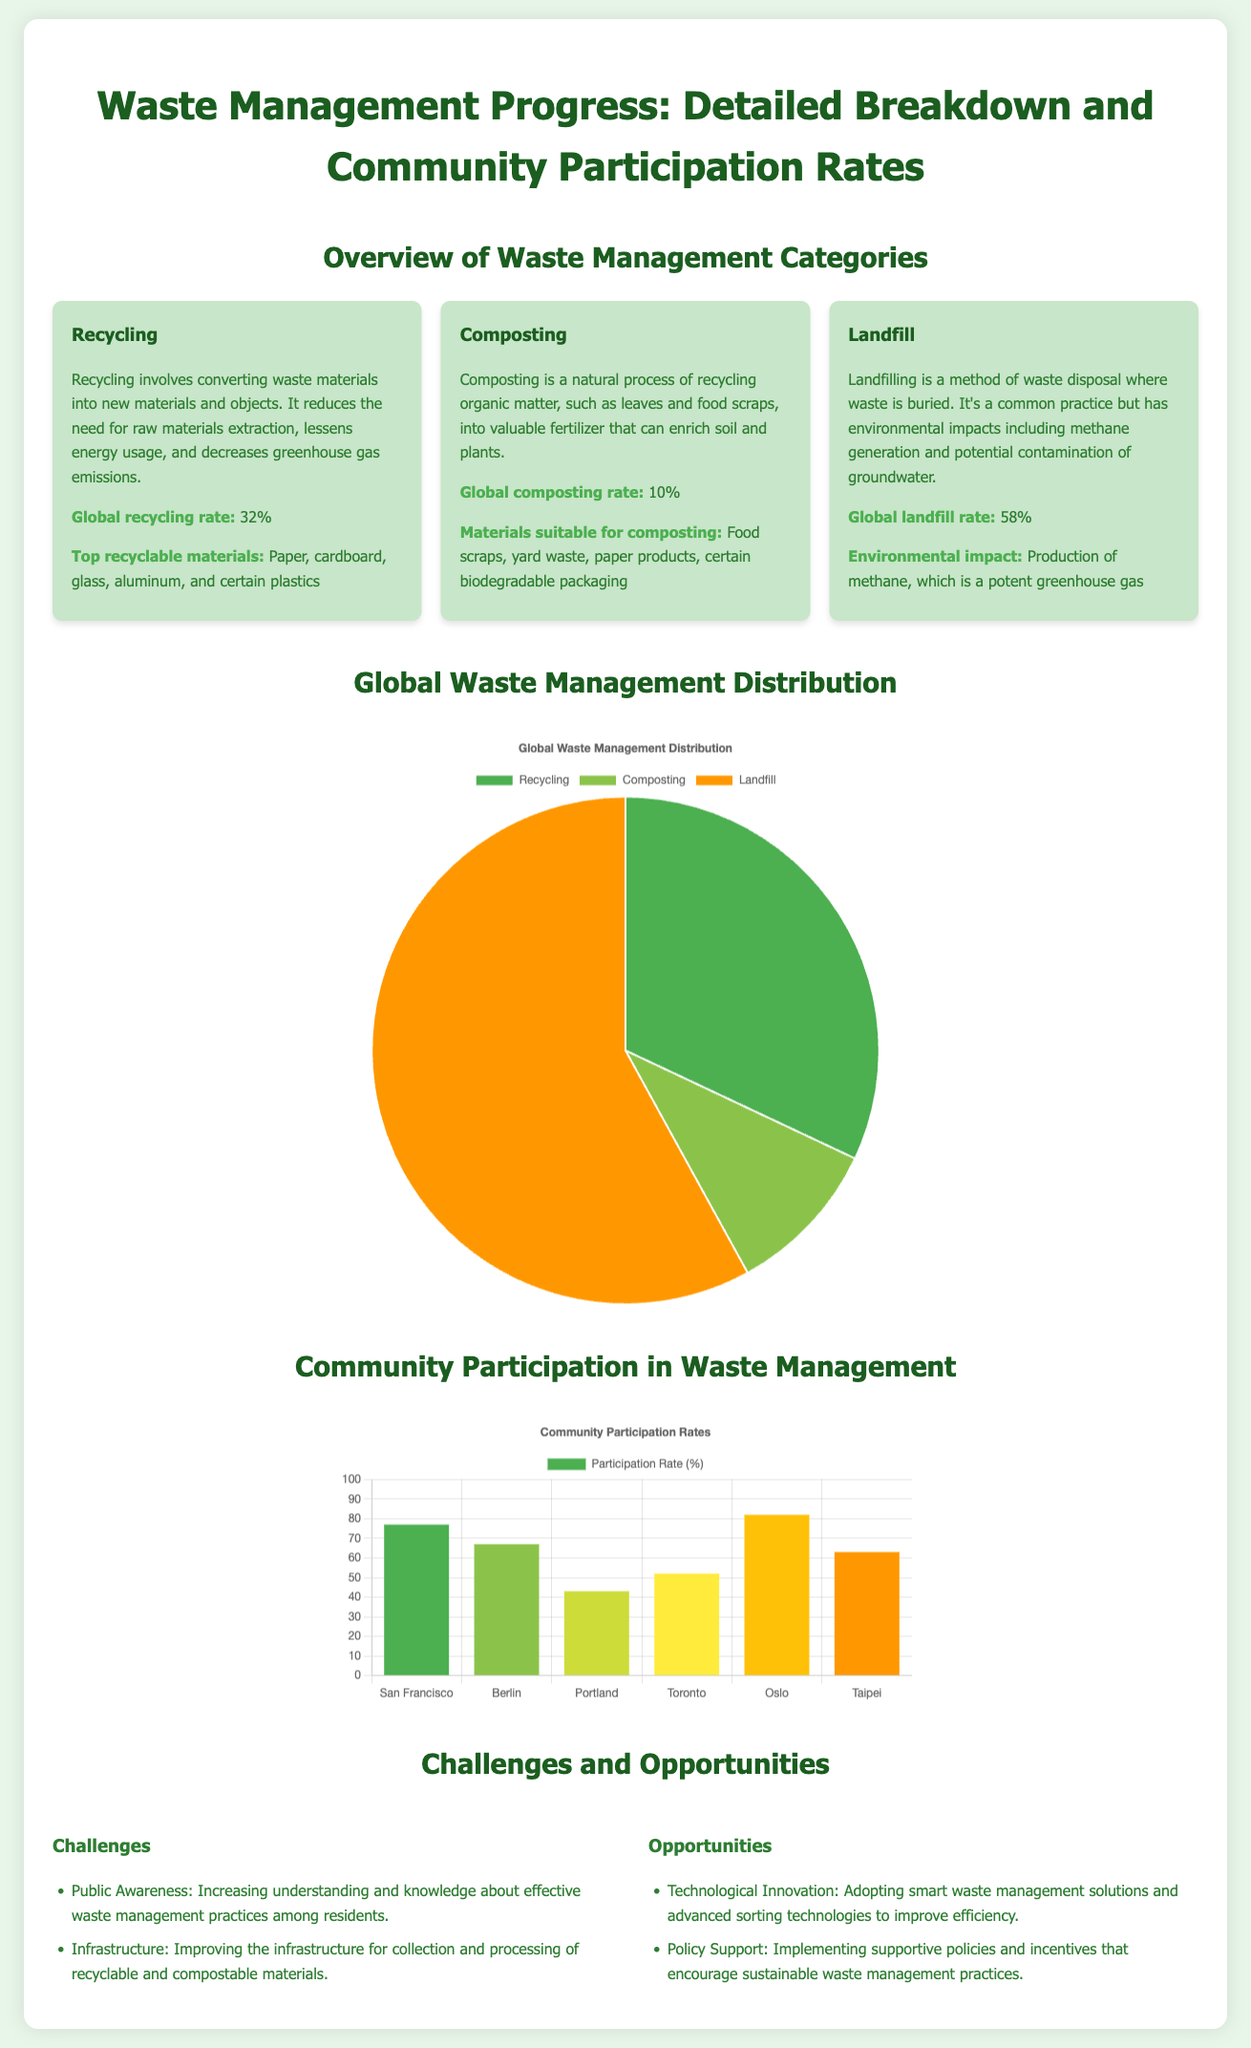what is the global recycling rate? The global recycling rate is stated in the document as 32%.
Answer: 32% what is the global composting rate? The global composting rate is listed as 10%.
Answer: 10% what is the global landfill rate? The global landfill rate mentioned in the document is 58%.
Answer: 58% which city has the highest community participation rate? From the community participation chart, San Francisco has the highest participation rate at 77%.
Answer: San Francisco what are the top recyclable materials? The document lists paper, cardboard, glass, aluminum, and certain plastics as the top recyclable materials.
Answer: Paper, cardboard, glass, aluminum, certain plastics what is one challenge mentioned in the document? The document states that one challenge is increasing public awareness about effective waste management practices.
Answer: Public Awareness what is one opportunity highlighted in the document? The document notes that adopting smart waste management solutions is an opportunity for improvement.
Answer: Technological Innovation what type of chart is used to represent community participation rates? The community participation rates are represented using a bar chart.
Answer: Bar chart what is the purpose of composting as mentioned in the document? The document states that composting involves recycling organic matter into valuable fertilizer.
Answer: Valuable fertilizer 